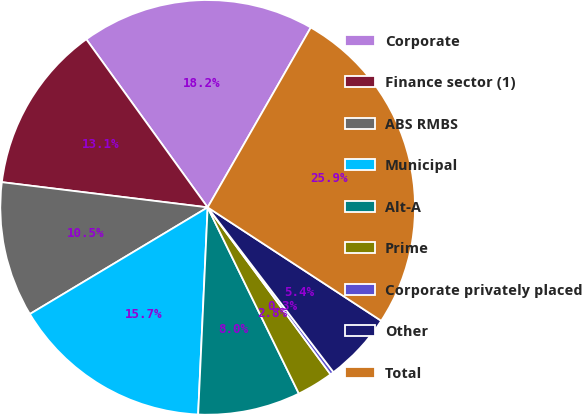Convert chart. <chart><loc_0><loc_0><loc_500><loc_500><pie_chart><fcel>Corporate<fcel>Finance sector (1)<fcel>ABS RMBS<fcel>Municipal<fcel>Alt-A<fcel>Prime<fcel>Corporate privately placed<fcel>Other<fcel>Total<nl><fcel>18.24%<fcel>13.11%<fcel>10.54%<fcel>15.67%<fcel>7.98%<fcel>2.85%<fcel>0.28%<fcel>5.41%<fcel>25.93%<nl></chart> 